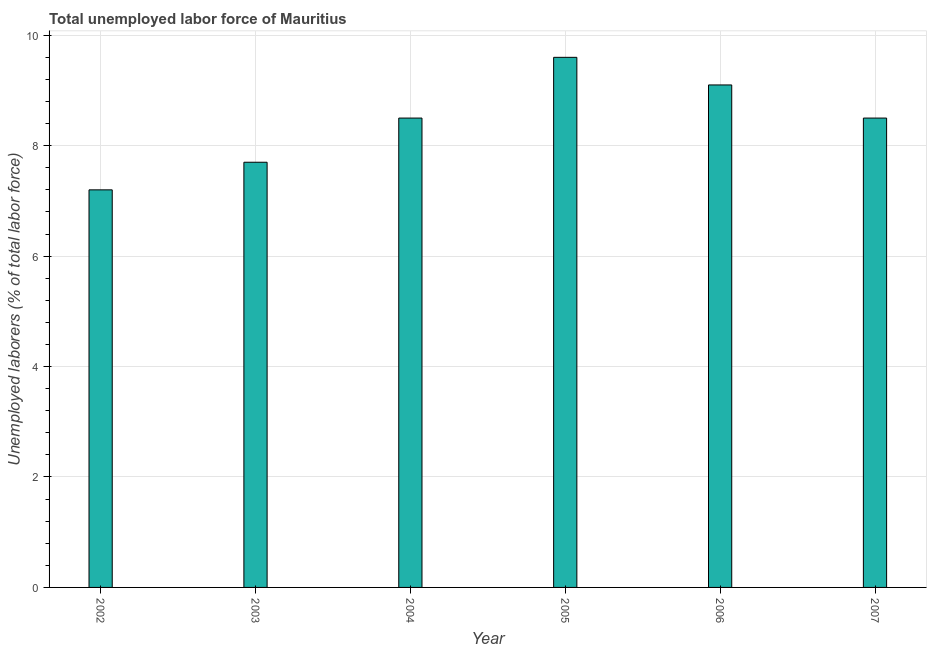Does the graph contain any zero values?
Make the answer very short. No. Does the graph contain grids?
Offer a terse response. Yes. What is the title of the graph?
Your response must be concise. Total unemployed labor force of Mauritius. What is the label or title of the X-axis?
Keep it short and to the point. Year. What is the label or title of the Y-axis?
Offer a very short reply. Unemployed laborers (% of total labor force). What is the total unemployed labour force in 2006?
Offer a very short reply. 9.1. Across all years, what is the maximum total unemployed labour force?
Your answer should be compact. 9.6. Across all years, what is the minimum total unemployed labour force?
Provide a short and direct response. 7.2. In which year was the total unemployed labour force maximum?
Provide a succinct answer. 2005. What is the sum of the total unemployed labour force?
Make the answer very short. 50.6. What is the average total unemployed labour force per year?
Ensure brevity in your answer.  8.43. What is the median total unemployed labour force?
Keep it short and to the point. 8.5. Do a majority of the years between 2007 and 2005 (inclusive) have total unemployed labour force greater than 5.6 %?
Offer a terse response. Yes. What is the ratio of the total unemployed labour force in 2002 to that in 2005?
Give a very brief answer. 0.75. What is the difference between the highest and the second highest total unemployed labour force?
Offer a terse response. 0.5. Is the sum of the total unemployed labour force in 2002 and 2003 greater than the maximum total unemployed labour force across all years?
Give a very brief answer. Yes. What is the difference between the highest and the lowest total unemployed labour force?
Offer a terse response. 2.4. What is the Unemployed laborers (% of total labor force) in 2002?
Your response must be concise. 7.2. What is the Unemployed laborers (% of total labor force) in 2003?
Offer a terse response. 7.7. What is the Unemployed laborers (% of total labor force) in 2004?
Offer a very short reply. 8.5. What is the Unemployed laborers (% of total labor force) of 2005?
Make the answer very short. 9.6. What is the Unemployed laborers (% of total labor force) of 2006?
Your response must be concise. 9.1. What is the Unemployed laborers (% of total labor force) of 2007?
Make the answer very short. 8.5. What is the difference between the Unemployed laborers (% of total labor force) in 2002 and 2005?
Offer a very short reply. -2.4. What is the difference between the Unemployed laborers (% of total labor force) in 2002 and 2007?
Provide a short and direct response. -1.3. What is the difference between the Unemployed laborers (% of total labor force) in 2003 and 2007?
Offer a very short reply. -0.8. What is the difference between the Unemployed laborers (% of total labor force) in 2004 and 2006?
Make the answer very short. -0.6. What is the difference between the Unemployed laborers (% of total labor force) in 2004 and 2007?
Make the answer very short. 0. What is the ratio of the Unemployed laborers (% of total labor force) in 2002 to that in 2003?
Provide a succinct answer. 0.94. What is the ratio of the Unemployed laborers (% of total labor force) in 2002 to that in 2004?
Give a very brief answer. 0.85. What is the ratio of the Unemployed laborers (% of total labor force) in 2002 to that in 2006?
Provide a succinct answer. 0.79. What is the ratio of the Unemployed laborers (% of total labor force) in 2002 to that in 2007?
Keep it short and to the point. 0.85. What is the ratio of the Unemployed laborers (% of total labor force) in 2003 to that in 2004?
Your response must be concise. 0.91. What is the ratio of the Unemployed laborers (% of total labor force) in 2003 to that in 2005?
Ensure brevity in your answer.  0.8. What is the ratio of the Unemployed laborers (% of total labor force) in 2003 to that in 2006?
Your answer should be very brief. 0.85. What is the ratio of the Unemployed laborers (% of total labor force) in 2003 to that in 2007?
Provide a succinct answer. 0.91. What is the ratio of the Unemployed laborers (% of total labor force) in 2004 to that in 2005?
Ensure brevity in your answer.  0.89. What is the ratio of the Unemployed laborers (% of total labor force) in 2004 to that in 2006?
Provide a short and direct response. 0.93. What is the ratio of the Unemployed laborers (% of total labor force) in 2005 to that in 2006?
Your response must be concise. 1.05. What is the ratio of the Unemployed laborers (% of total labor force) in 2005 to that in 2007?
Your answer should be compact. 1.13. What is the ratio of the Unemployed laborers (% of total labor force) in 2006 to that in 2007?
Your answer should be compact. 1.07. 